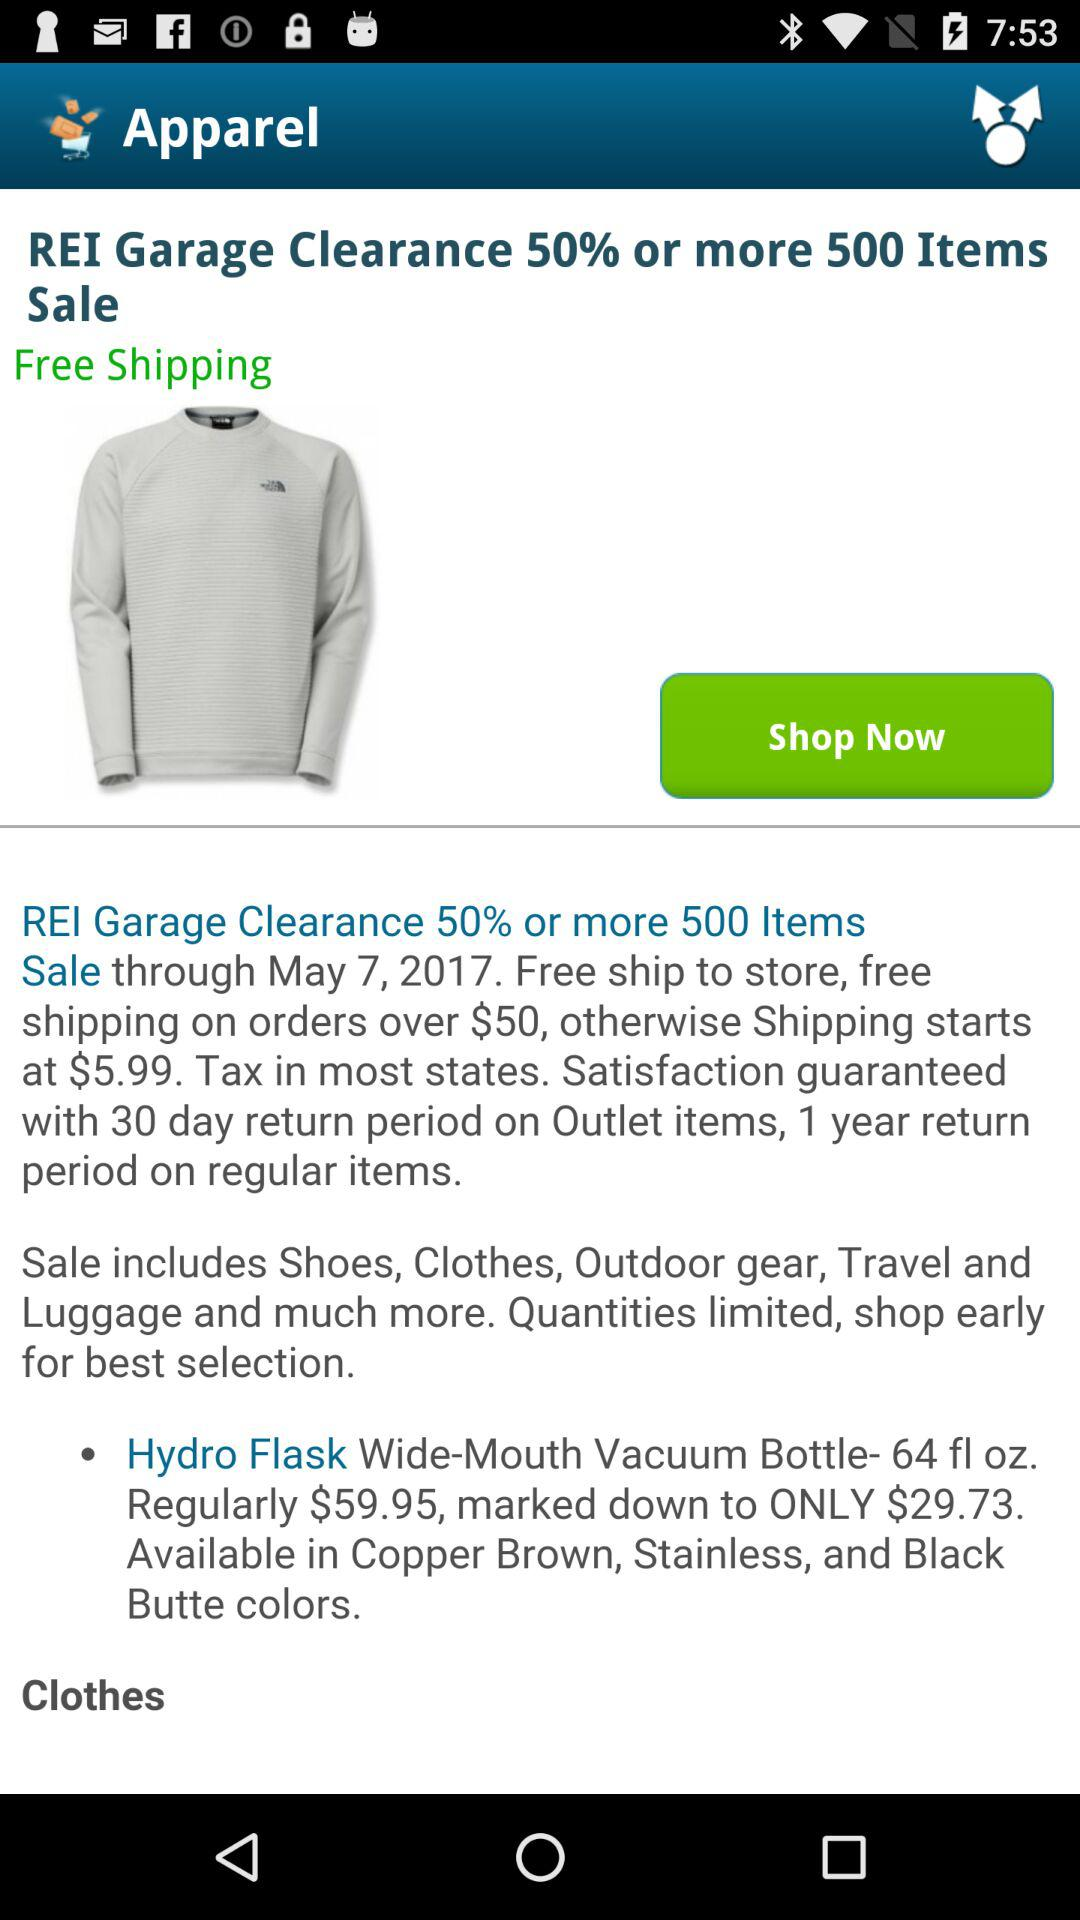At what date does the REI garage clearance sale start up? The REI garage clearance sale starts up on May 7, 2017. 